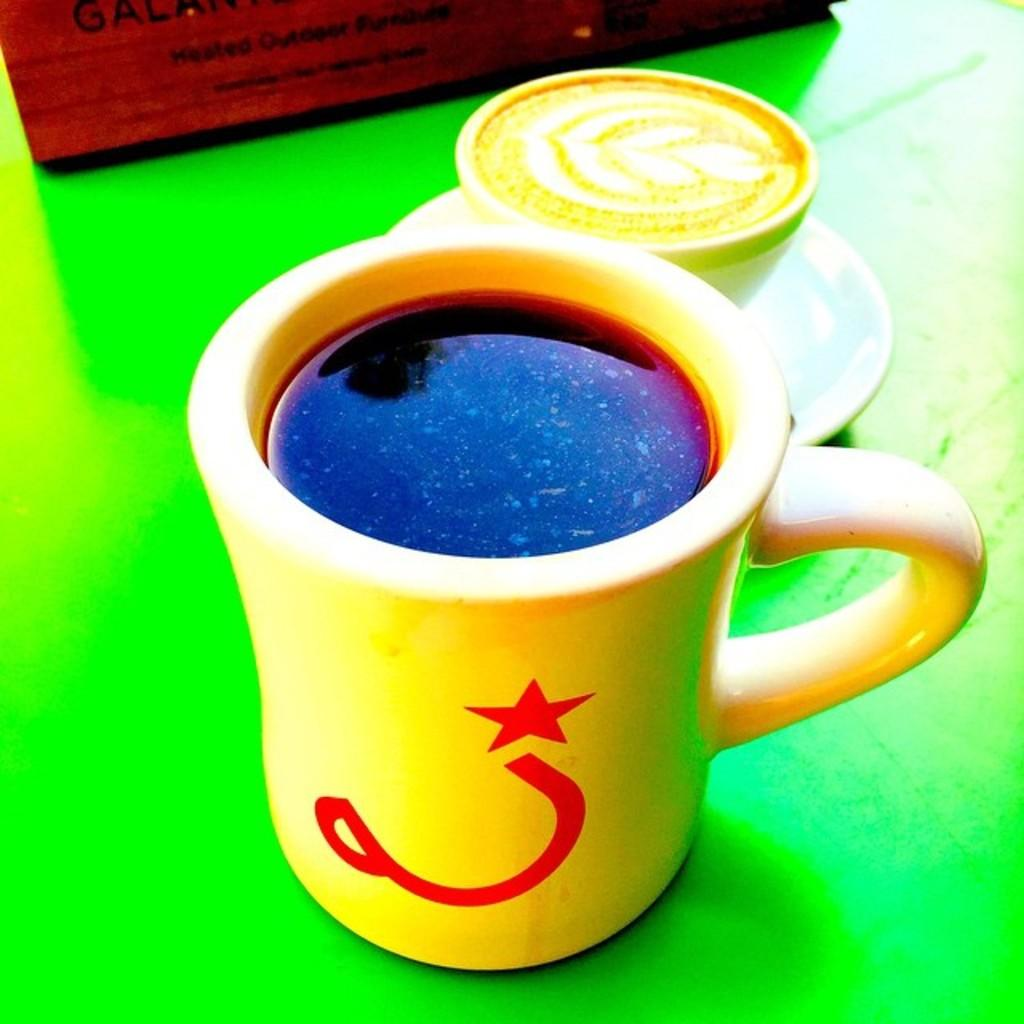How many cups can be seen in the image? There are two cups in the image. What is the color of the surface on which the cups are placed? The cups are on a green surface. What type of bell can be heard ringing during the meal in the image? There is no bell or meal present in the image; it only features two cups on a green surface. How many birds are visible in the image? There are no birds present in the image. 